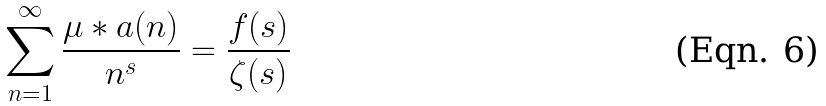<formula> <loc_0><loc_0><loc_500><loc_500>\sum _ { n = 1 } ^ { \infty } \frac { \mu * a ( n ) } { n ^ { s } } = \frac { f ( s ) } { \zeta ( s ) }</formula> 